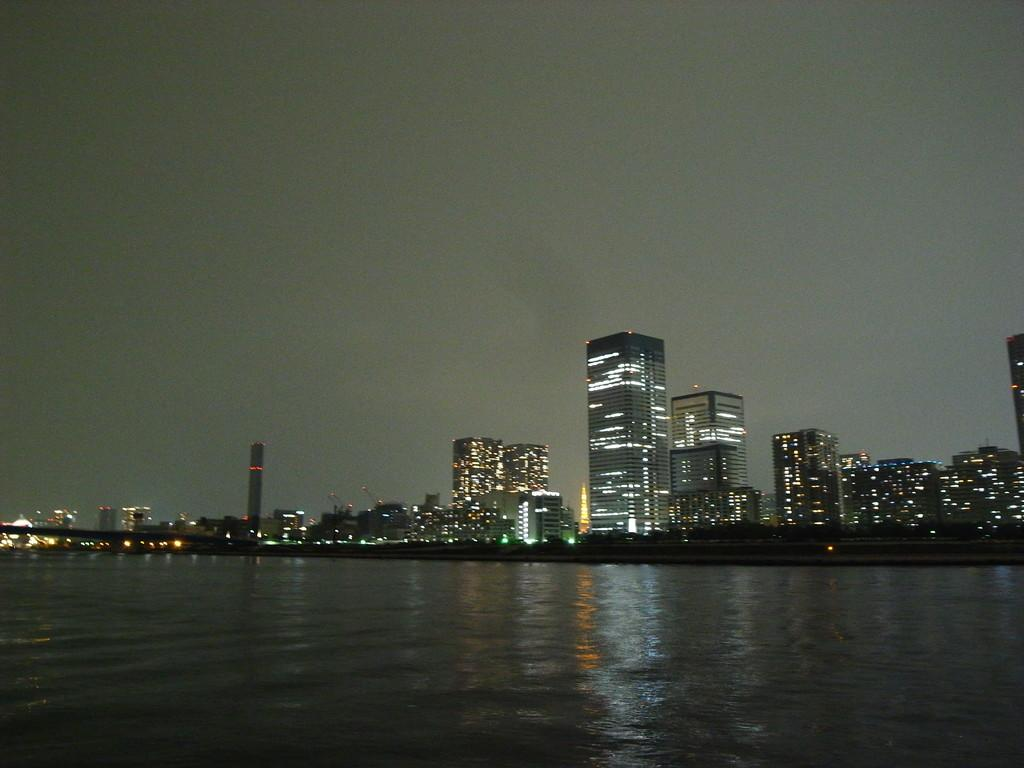What is visible in the image? Water is visible in the image. What can be seen in the background of the image? There are buildings and lights in the background of the image. Can you see any yaks in the image? There are no yaks present in the image. What type of bubble can be seen floating on the water in the image? There are no bubbles present in the image. 